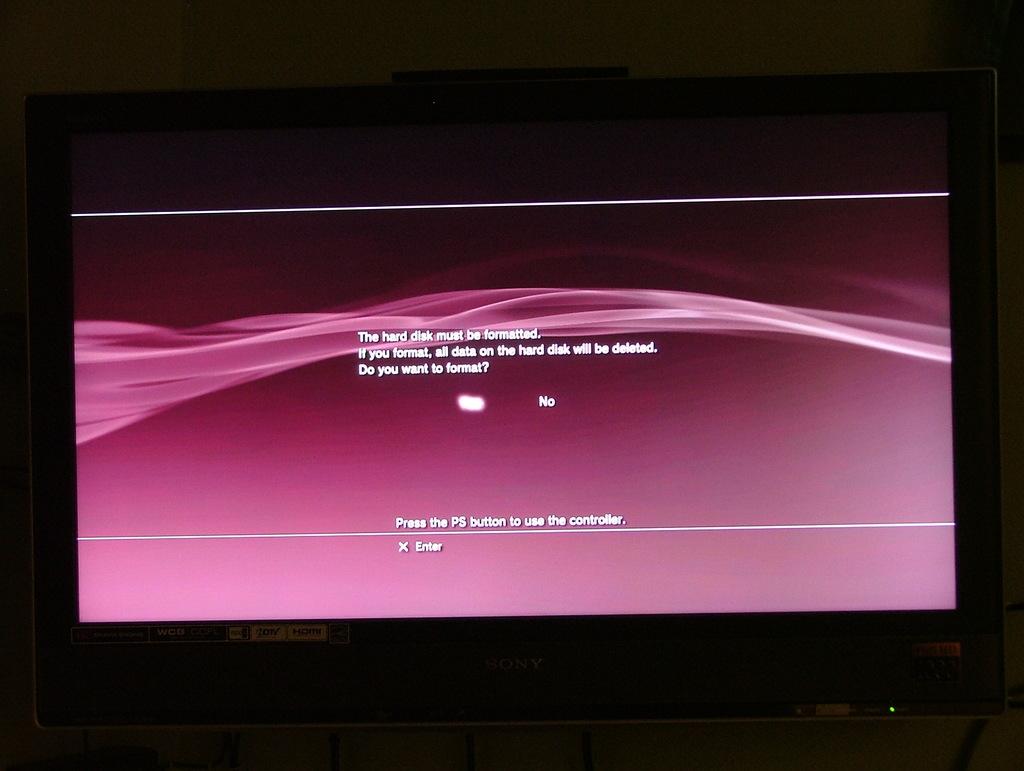What are you supposed to press?
Provide a short and direct response. Ps button. What must be formatted?
Provide a succinct answer. Hard disk. 